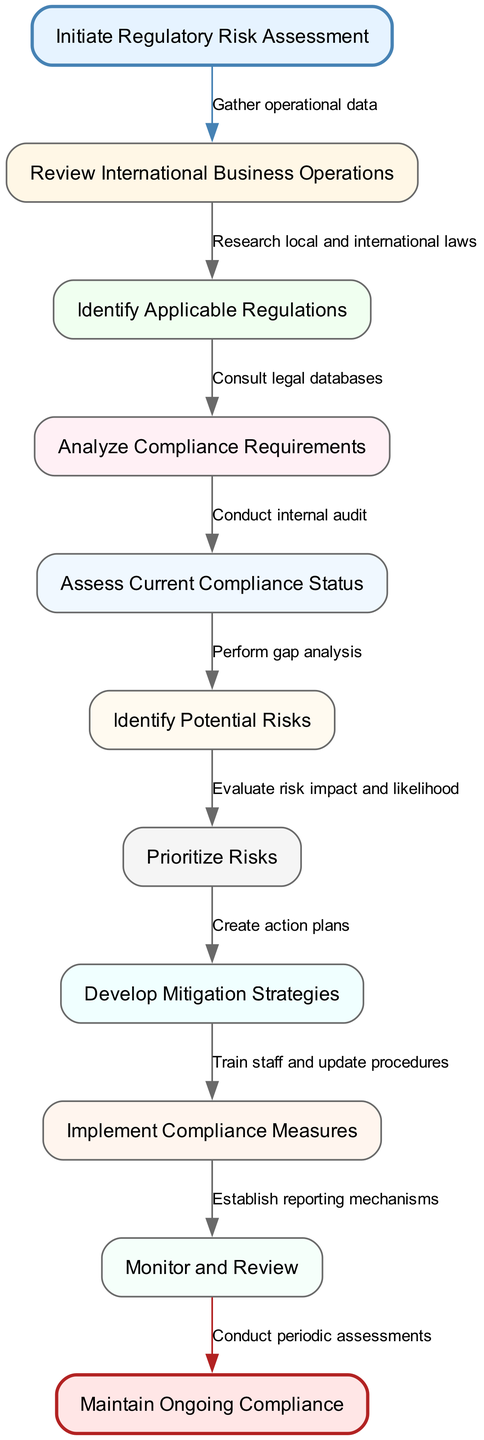What is the starting point of the workflow? The diagram identifies "Initiate Regulatory Risk Assessment" as the starting point, which is the first node connected to the start node.
Answer: Initiate Regulatory Risk Assessment How many nodes are present in the workflow? The diagram lists 9 nodes total: 1 start node, 8 main process nodes, and 1 end node. Counting these gives us 10 nodes.
Answer: 10 What is the last step before achieving ongoing compliance? The last step before reaching "Maintain Ongoing Compliance" is "Conduct periodic assessments," which is indicated as the edge leading from the final process node to the end node.
Answer: Conduct periodic assessments Which step comes directly after "Analyze Compliance Requirements"? "Assess Current Compliance Status" is the step that follows "Analyze Compliance Requirements." The flow chart shows a direct connection from one node to the next.
Answer: Assess Current Compliance Status How many edges are in the workflow diagram? Edges indicate connections between nodes. The flow chart has 9 edges: 1 from the start node to the first process node and 8 between subsequent nodes to the end node.
Answer: 9 What node corresponds with the action "Evaluate risk impact and likelihood"? The action "Evaluate risk impact and likelihood" corresponds to the node "Prioritize Risks," which is indicated along with its associated edge in the workflow diagram.
Answer: Prioritize Risks Which is the first regulatory requirement to be examined in the process? The first regulatory requirement examined in the process is identified as "Review International Business Operations," following the starting node.
Answer: Review International Business Operations What type of analysis is performed after "Conduct internal audit"? A "gap analysis" is performed after the "Conduct internal audit" step, as indicated by the connections in the workflow.
Answer: gap analysis Which node includes the action of "Train staff and update procedures"? The action "Train staff and update procedures" is included in the node labeled "Implement Compliance Measures," as shown in the workflow.
Answer: Implement Compliance Measures 